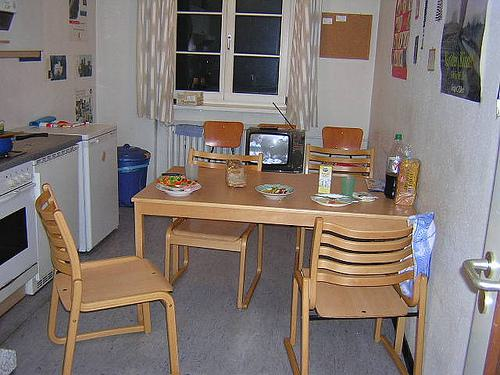What time of day does it appear to be in the image? Based on the artificial lighting and darkness outside the window, it appears to be evening or nighttime in the image. 